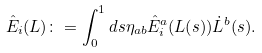Convert formula to latex. <formula><loc_0><loc_0><loc_500><loc_500>\hat { E } _ { i } ( L ) \colon = \int _ { 0 } ^ { 1 } d s \eta _ { a b } \hat { E } _ { i } ^ { a } ( L ( s ) ) \dot { L } ^ { b } ( s ) .</formula> 